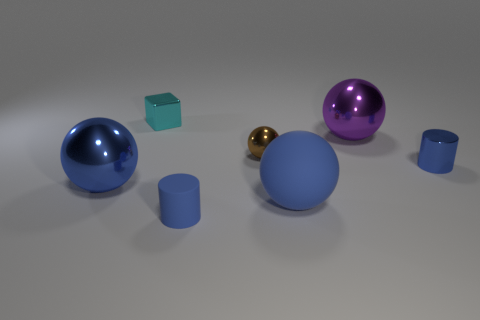There is another tiny cylinder that is the same color as the metal cylinder; what is it made of?
Your answer should be compact. Rubber. Is there a sphere of the same color as the big rubber thing?
Your answer should be compact. Yes. There is a rubber sphere; is it the same color as the small thing that is in front of the blue metallic ball?
Make the answer very short. Yes. What is the size of the brown thing that is the same shape as the large blue matte thing?
Give a very brief answer. Small. There is a ball that is in front of the brown sphere and on the right side of the small brown metal thing; what material is it made of?
Provide a succinct answer. Rubber. Is the number of brown things on the right side of the small brown ball the same as the number of big cyan balls?
Your answer should be very brief. Yes. What number of things are large shiny things on the left side of the tiny blue metallic cylinder or tiny blue rubber things?
Your response must be concise. 3. Do the large metallic ball that is left of the rubber sphere and the small rubber thing have the same color?
Your response must be concise. Yes. What is the size of the metal object in front of the small blue metallic cylinder?
Offer a very short reply. Large. There is a large blue object that is in front of the big blue sphere that is to the left of the block; what shape is it?
Keep it short and to the point. Sphere. 